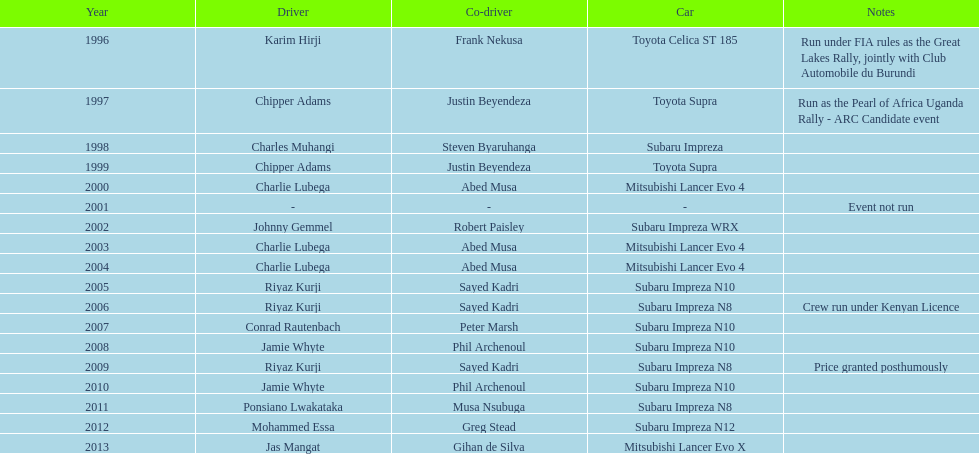Chipper adams and justin beyendeza have how mnay wins? 2. 